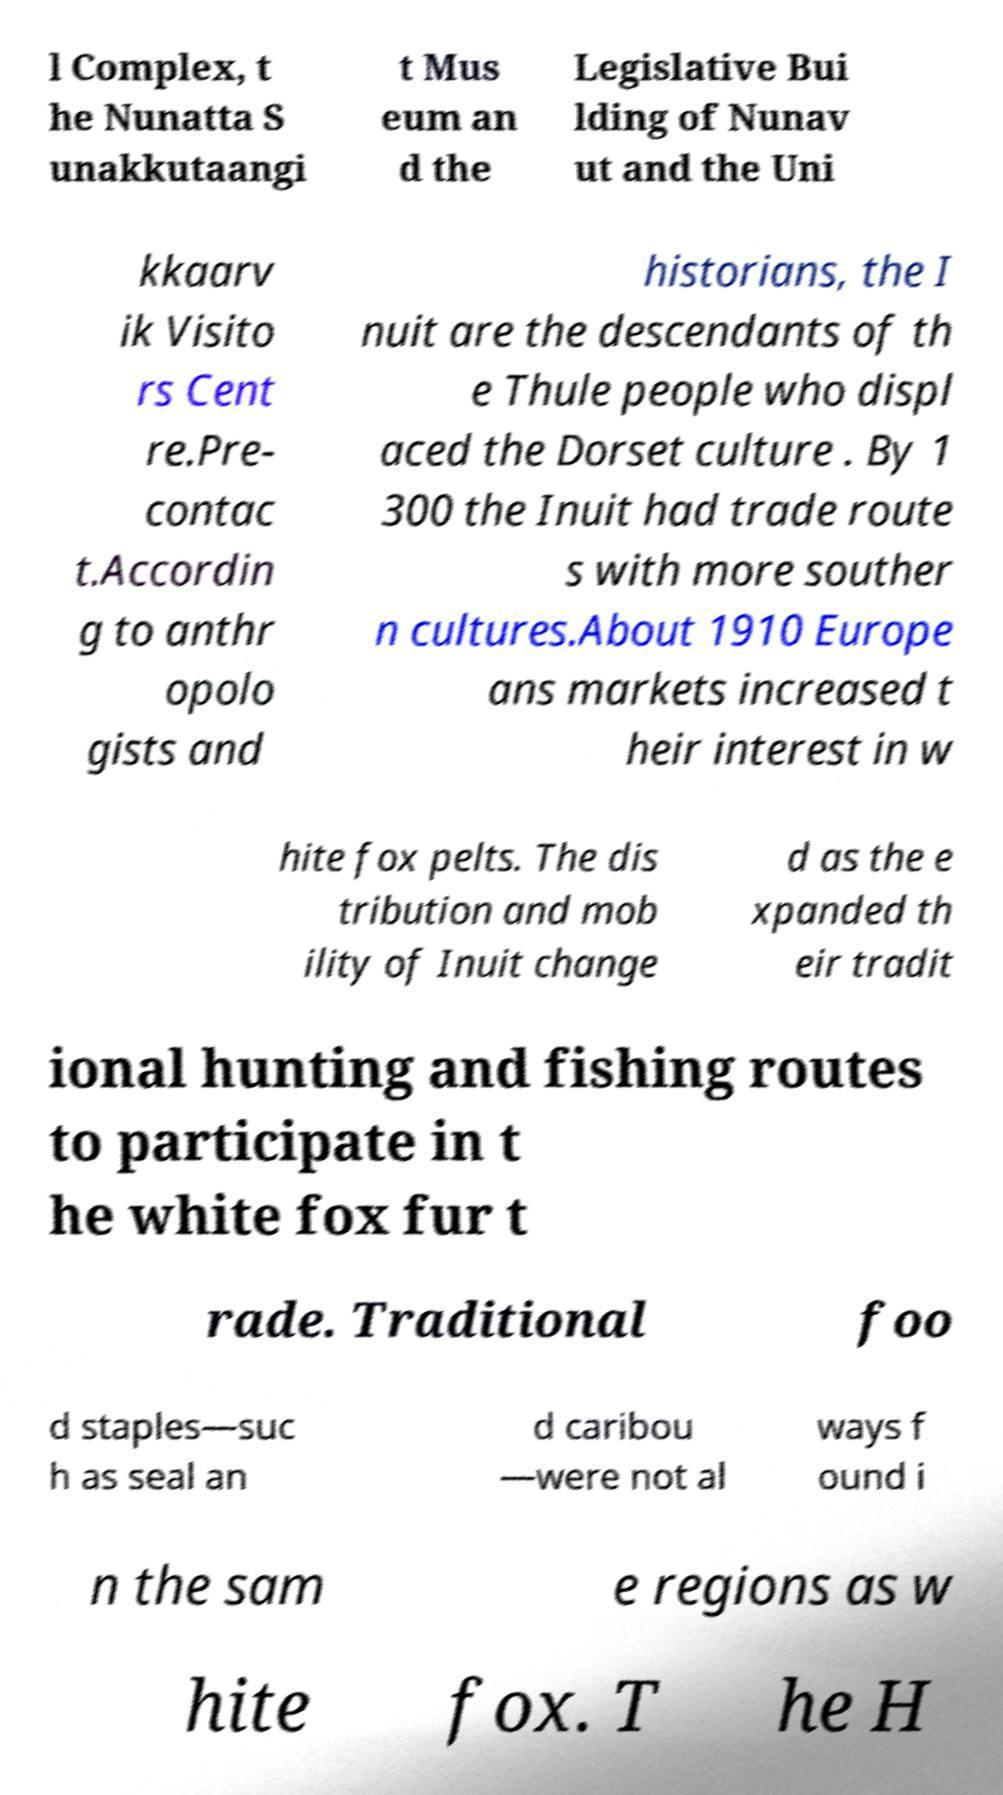What messages or text are displayed in this image? I need them in a readable, typed format. l Complex, t he Nunatta S unakkutaangi t Mus eum an d the Legislative Bui lding of Nunav ut and the Uni kkaarv ik Visito rs Cent re.Pre- contac t.Accordin g to anthr opolo gists and historians, the I nuit are the descendants of th e Thule people who displ aced the Dorset culture . By 1 300 the Inuit had trade route s with more souther n cultures.About 1910 Europe ans markets increased t heir interest in w hite fox pelts. The dis tribution and mob ility of Inuit change d as the e xpanded th eir tradit ional hunting and fishing routes to participate in t he white fox fur t rade. Traditional foo d staples—suc h as seal an d caribou —were not al ways f ound i n the sam e regions as w hite fox. T he H 